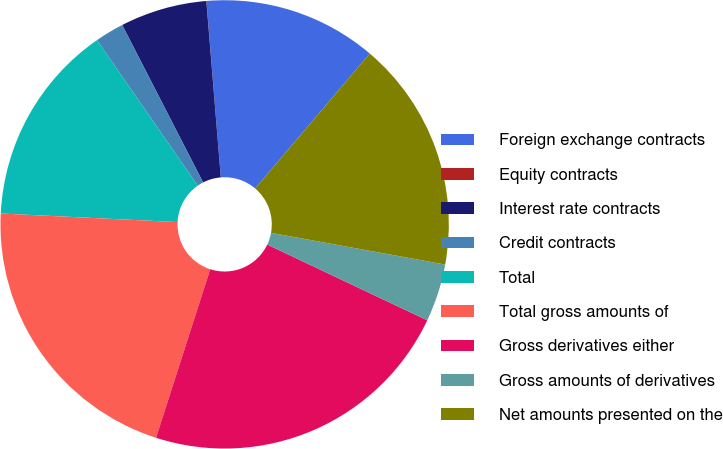<chart> <loc_0><loc_0><loc_500><loc_500><pie_chart><fcel>Foreign exchange contracts<fcel>Equity contracts<fcel>Interest rate contracts<fcel>Credit contracts<fcel>Total<fcel>Total gross amounts of<fcel>Gross derivatives either<fcel>Gross amounts of derivatives<fcel>Net amounts presented on the<nl><fcel>12.5%<fcel>0.01%<fcel>6.25%<fcel>2.09%<fcel>14.58%<fcel>20.82%<fcel>22.91%<fcel>4.17%<fcel>16.66%<nl></chart> 